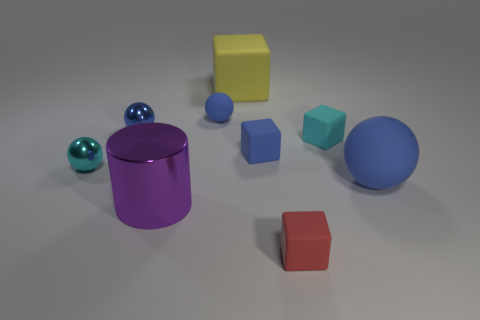Subtract all blue balls. How many were subtracted if there are1blue balls left? 2 Subtract all gray cylinders. How many blue spheres are left? 3 Add 1 large gray metal things. How many objects exist? 10 Subtract all cylinders. How many objects are left? 8 Subtract 0 brown balls. How many objects are left? 9 Subtract all small objects. Subtract all tiny cyan spheres. How many objects are left? 2 Add 1 large purple things. How many large purple things are left? 2 Add 4 red blocks. How many red blocks exist? 5 